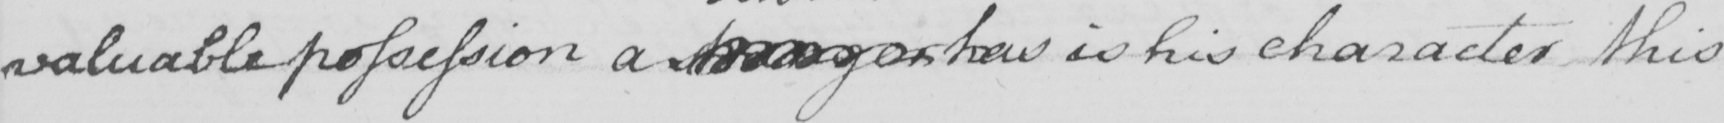What text is written in this handwritten line? valuable possession a stranger has is his character this 